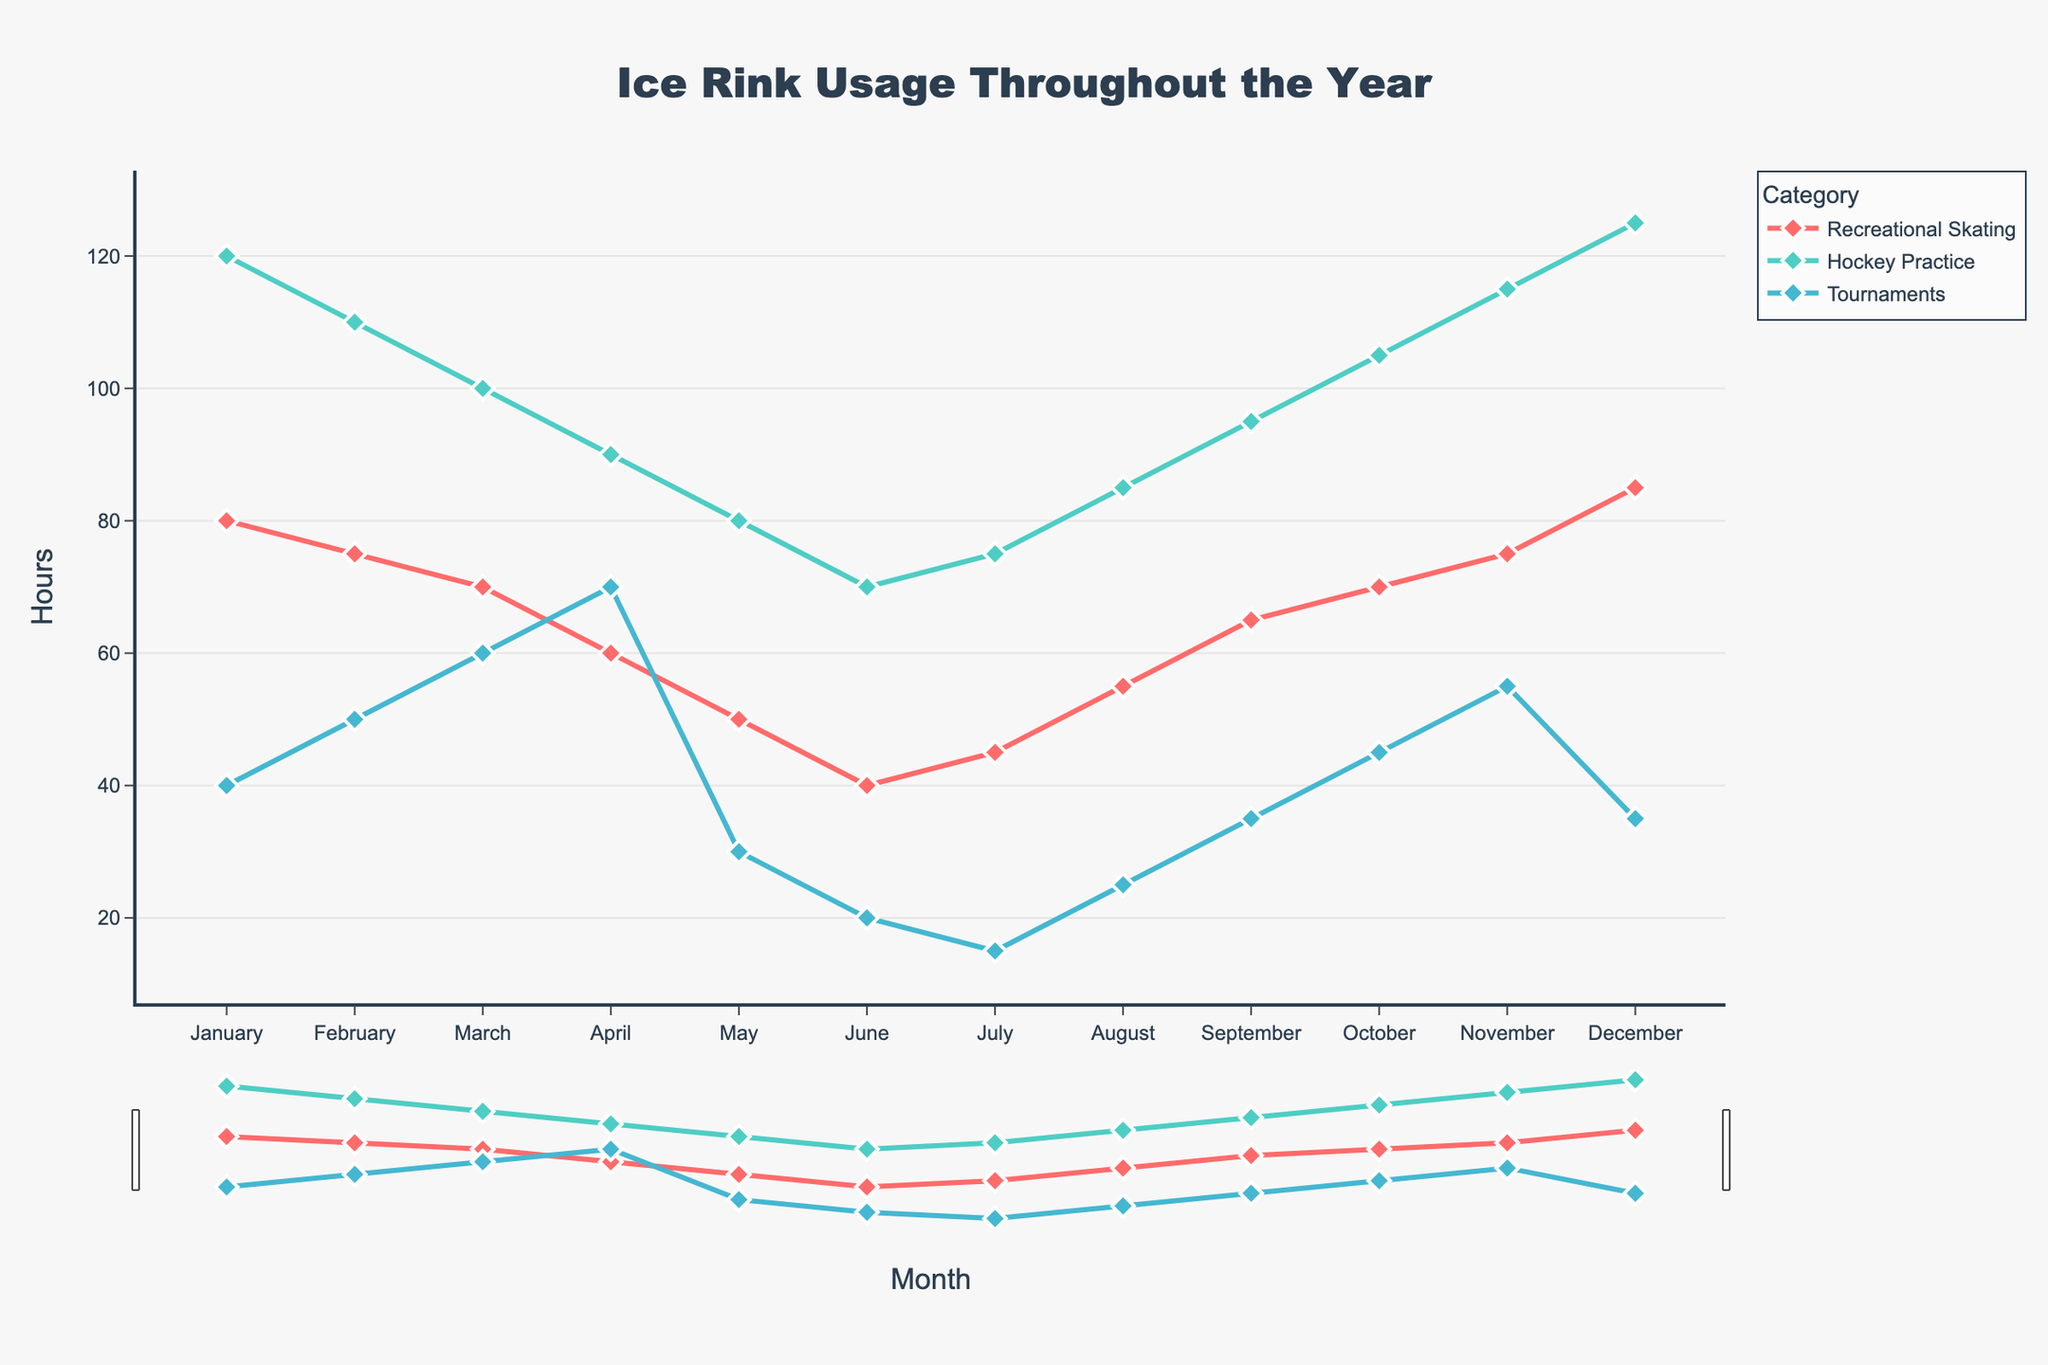What month has the highest usage for recreational skating? The highest point in the "Recreational Skating" line appears in December. By looking at the y-axis value in December, it is clear that the number of hours used is highest in that month.
Answer: December Which category has the most consistent usage throughout the year? The "Hockey Practice" line appears the smoothest and closest to a horizontal line, indicating its usage fluctuates less dramatically compared to the other categories.
Answer: Hockey Practice What is the total usage for tournaments in the first quarter (Jan - Mar)? Summing up the tournament hours in January (40), February (50), and March (60): 40 + 50 + 60 = 150 hours.
Answer: 150 hours In which month does hockey practice usage peak, and what is its value? The peak in the "Hockey Practice" line occurs in December where it reaches the highest point. By looking at the y-axis value in December, the peak usage is 125 hours.
Answer: December, 125 hours Compare the usage of tournaments in May and September and determine the difference. The usage for tournaments in May is 30 hours, and in September, it is 35 hours. The difference is 35 - 30 = 5 hours.
Answer: 5 hours Which month shows the least usage across all categories combined? Adding up all categories for each month and comparing, the lowest combined total is in June: Recreational Skating (40) + Hockey Practice (70) + Tournaments (20) = 130 hours.
Answer: June, 130 hours By how many hours does recreational skating usage increase from June to December? The hours in June for recreational skating is 40 and in December is 85. The increase is 85 - 40 = 45 hours.
Answer: 45 hours Is there any month where recreational skating and hockey practice have the same usage values? By examining the figure month by month, there is no month where "Recreational Skating" and "Hockey Practice" lines intersect or share the same value.
Answer: No What is the average monthly usage for tournaments? Summing up all values for tournaments across each month and dividing by 12: (40 + 50 + 60 + 70 + 30 + 20 + 15 + 25 + 35 + 45 + 55 + 35) / 12 = 41.67 hours.
Answer: 41.67 hours 